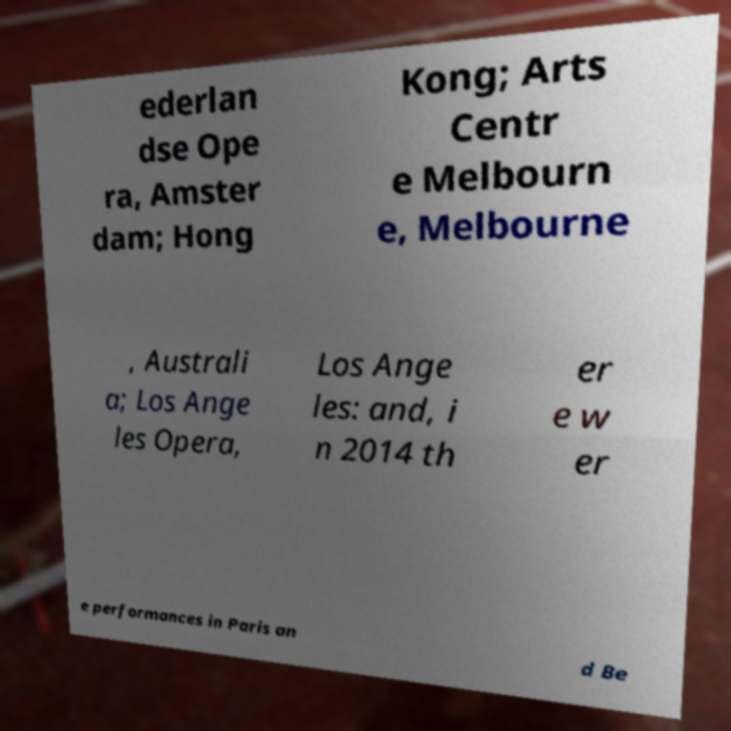I need the written content from this picture converted into text. Can you do that? ederlan dse Ope ra, Amster dam; Hong Kong; Arts Centr e Melbourn e, Melbourne , Australi a; Los Ange les Opera, Los Ange les: and, i n 2014 th er e w er e performances in Paris an d Be 